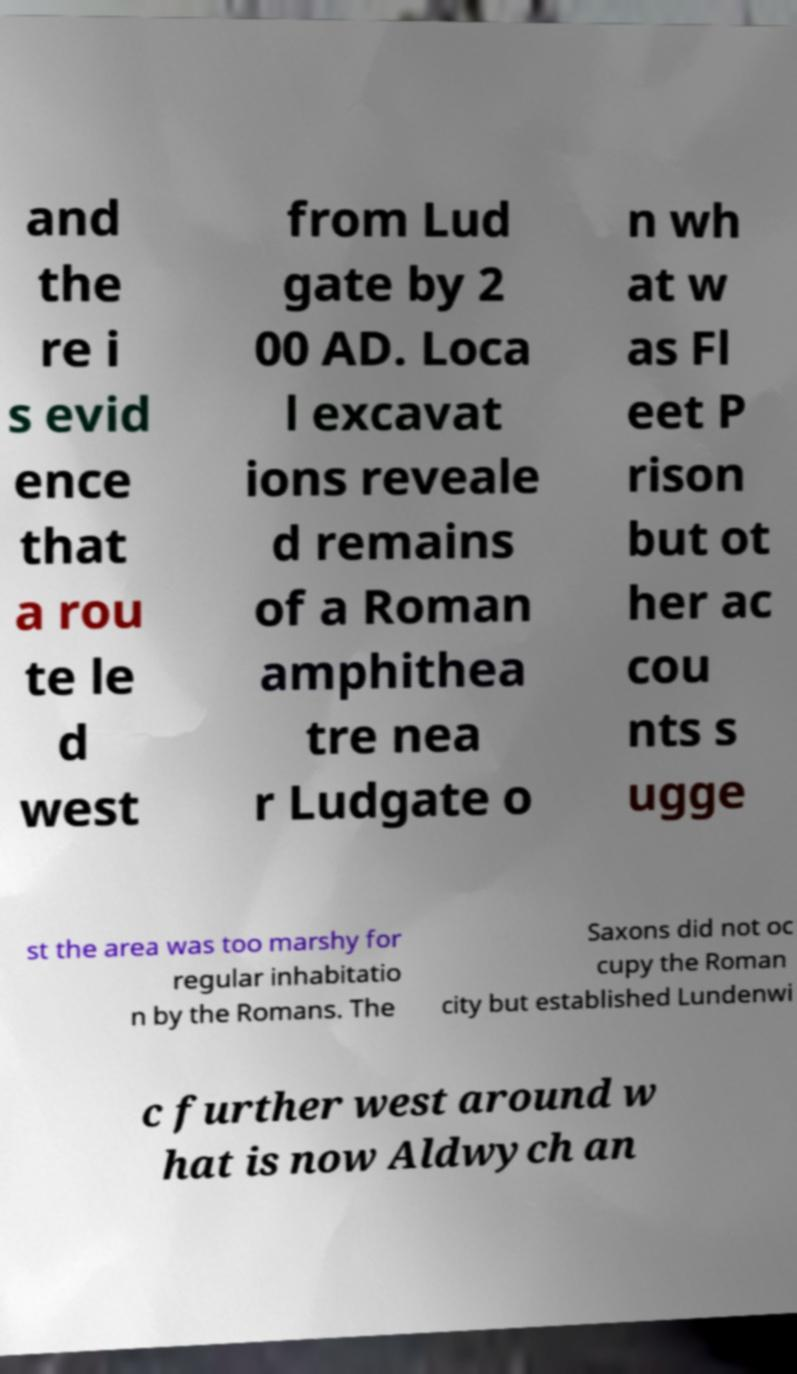Could you assist in decoding the text presented in this image and type it out clearly? and the re i s evid ence that a rou te le d west from Lud gate by 2 00 AD. Loca l excavat ions reveale d remains of a Roman amphithea tre nea r Ludgate o n wh at w as Fl eet P rison but ot her ac cou nts s ugge st the area was too marshy for regular inhabitatio n by the Romans. The Saxons did not oc cupy the Roman city but established Lundenwi c further west around w hat is now Aldwych an 